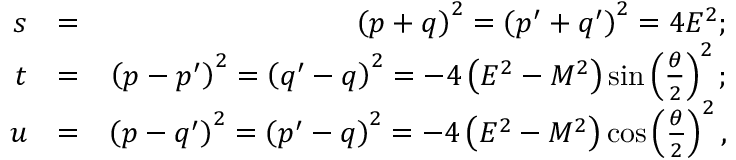<formula> <loc_0><loc_0><loc_500><loc_500>\begin{array} { r l r } { s } & { = } & { \left ( p + q \right ) ^ { 2 } = \left ( p ^ { \prime } + q ^ { \prime } \right ) ^ { 2 } = 4 E ^ { 2 } ; } \\ { t } & { = } & { \left ( p - p ^ { \prime } \right ) ^ { 2 } = \left ( q ^ { \prime } - q \right ) ^ { 2 } = - 4 \left ( E ^ { 2 } - M ^ { 2 } \right ) \sin \left ( \frac { \theta } { 2 } \right ) ^ { 2 } ; } \\ { u } & { = } & { \left ( p - q ^ { \prime } \right ) ^ { 2 } = \left ( p ^ { \prime } - q \right ) ^ { 2 } = - 4 \left ( E ^ { 2 } - M ^ { 2 } \right ) \cos \left ( \frac { \theta } { 2 } \right ) ^ { 2 } , } \end{array}</formula> 